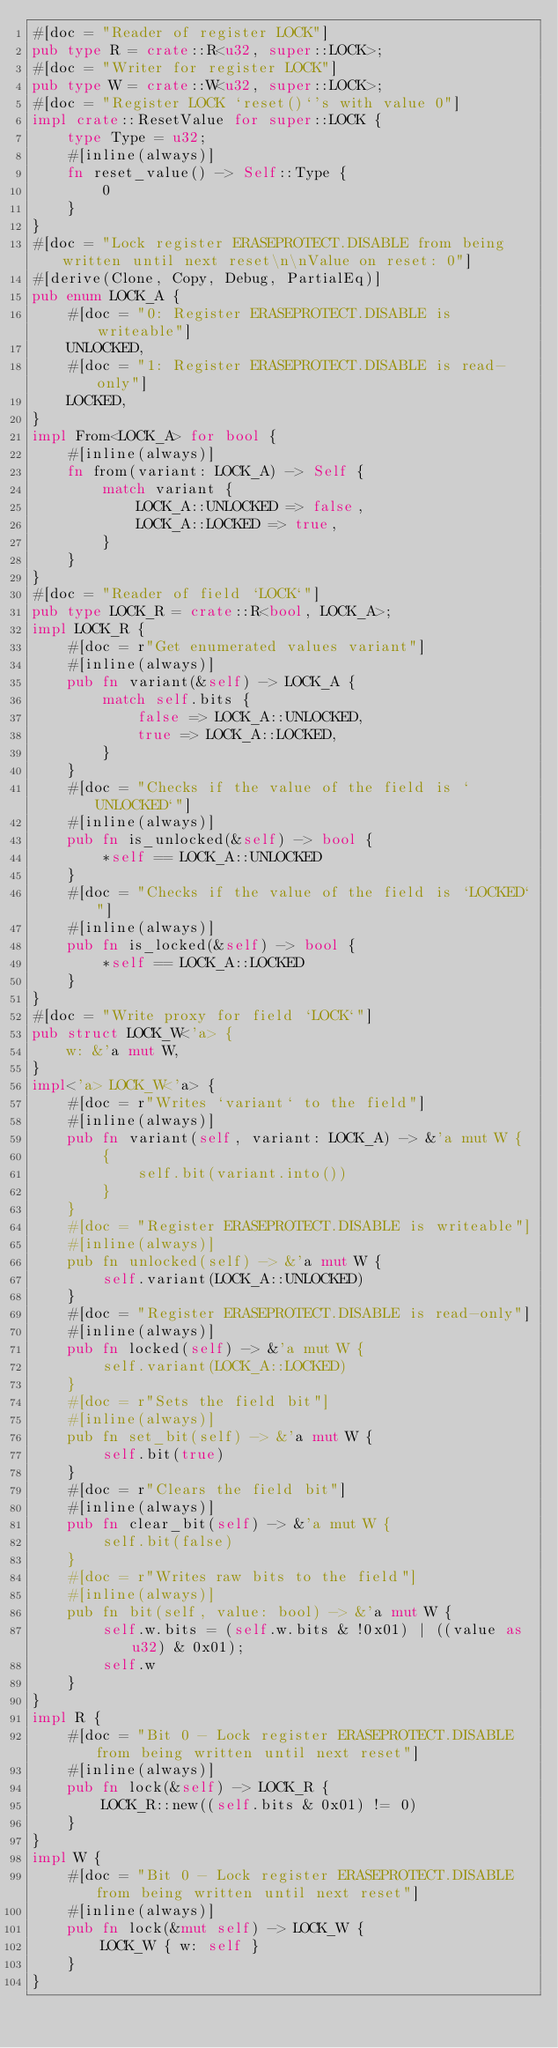<code> <loc_0><loc_0><loc_500><loc_500><_Rust_>#[doc = "Reader of register LOCK"]
pub type R = crate::R<u32, super::LOCK>;
#[doc = "Writer for register LOCK"]
pub type W = crate::W<u32, super::LOCK>;
#[doc = "Register LOCK `reset()`'s with value 0"]
impl crate::ResetValue for super::LOCK {
    type Type = u32;
    #[inline(always)]
    fn reset_value() -> Self::Type {
        0
    }
}
#[doc = "Lock register ERASEPROTECT.DISABLE from being written until next reset\n\nValue on reset: 0"]
#[derive(Clone, Copy, Debug, PartialEq)]
pub enum LOCK_A {
    #[doc = "0: Register ERASEPROTECT.DISABLE is writeable"]
    UNLOCKED,
    #[doc = "1: Register ERASEPROTECT.DISABLE is read-only"]
    LOCKED,
}
impl From<LOCK_A> for bool {
    #[inline(always)]
    fn from(variant: LOCK_A) -> Self {
        match variant {
            LOCK_A::UNLOCKED => false,
            LOCK_A::LOCKED => true,
        }
    }
}
#[doc = "Reader of field `LOCK`"]
pub type LOCK_R = crate::R<bool, LOCK_A>;
impl LOCK_R {
    #[doc = r"Get enumerated values variant"]
    #[inline(always)]
    pub fn variant(&self) -> LOCK_A {
        match self.bits {
            false => LOCK_A::UNLOCKED,
            true => LOCK_A::LOCKED,
        }
    }
    #[doc = "Checks if the value of the field is `UNLOCKED`"]
    #[inline(always)]
    pub fn is_unlocked(&self) -> bool {
        *self == LOCK_A::UNLOCKED
    }
    #[doc = "Checks if the value of the field is `LOCKED`"]
    #[inline(always)]
    pub fn is_locked(&self) -> bool {
        *self == LOCK_A::LOCKED
    }
}
#[doc = "Write proxy for field `LOCK`"]
pub struct LOCK_W<'a> {
    w: &'a mut W,
}
impl<'a> LOCK_W<'a> {
    #[doc = r"Writes `variant` to the field"]
    #[inline(always)]
    pub fn variant(self, variant: LOCK_A) -> &'a mut W {
        {
            self.bit(variant.into())
        }
    }
    #[doc = "Register ERASEPROTECT.DISABLE is writeable"]
    #[inline(always)]
    pub fn unlocked(self) -> &'a mut W {
        self.variant(LOCK_A::UNLOCKED)
    }
    #[doc = "Register ERASEPROTECT.DISABLE is read-only"]
    #[inline(always)]
    pub fn locked(self) -> &'a mut W {
        self.variant(LOCK_A::LOCKED)
    }
    #[doc = r"Sets the field bit"]
    #[inline(always)]
    pub fn set_bit(self) -> &'a mut W {
        self.bit(true)
    }
    #[doc = r"Clears the field bit"]
    #[inline(always)]
    pub fn clear_bit(self) -> &'a mut W {
        self.bit(false)
    }
    #[doc = r"Writes raw bits to the field"]
    #[inline(always)]
    pub fn bit(self, value: bool) -> &'a mut W {
        self.w.bits = (self.w.bits & !0x01) | ((value as u32) & 0x01);
        self.w
    }
}
impl R {
    #[doc = "Bit 0 - Lock register ERASEPROTECT.DISABLE from being written until next reset"]
    #[inline(always)]
    pub fn lock(&self) -> LOCK_R {
        LOCK_R::new((self.bits & 0x01) != 0)
    }
}
impl W {
    #[doc = "Bit 0 - Lock register ERASEPROTECT.DISABLE from being written until next reset"]
    #[inline(always)]
    pub fn lock(&mut self) -> LOCK_W {
        LOCK_W { w: self }
    }
}
</code> 